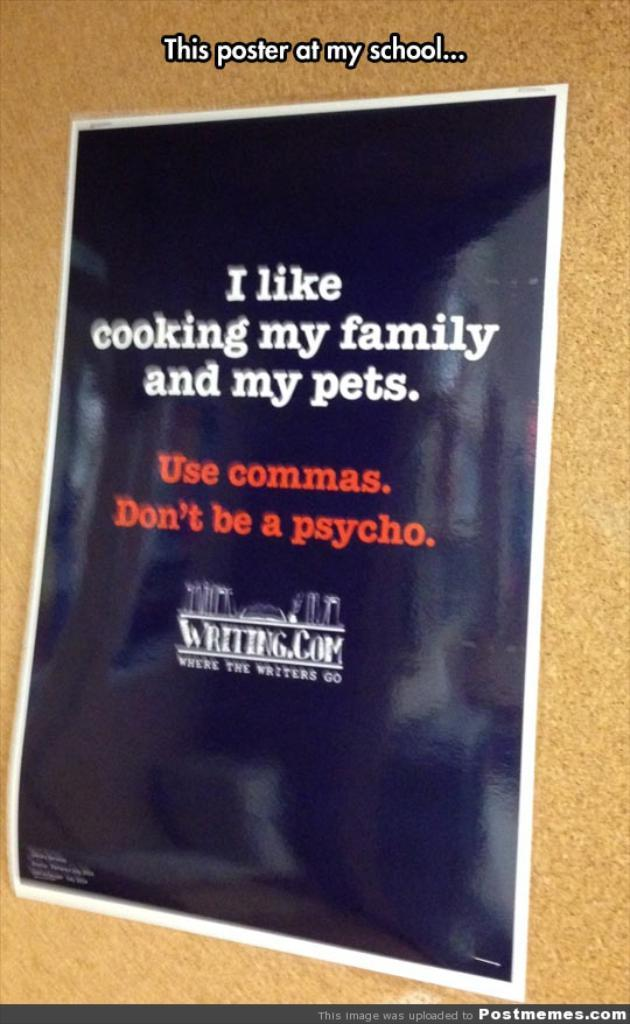Provide a one-sentence caption for the provided image. a poster that tells people to use commas. 